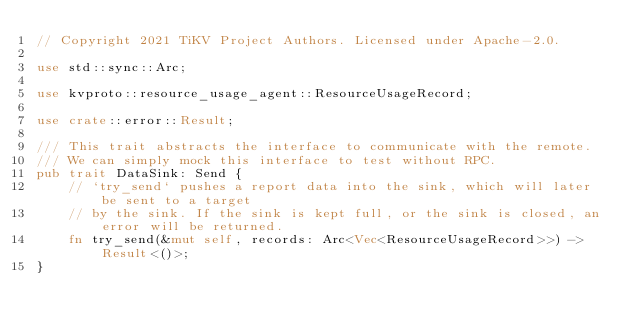<code> <loc_0><loc_0><loc_500><loc_500><_Rust_>// Copyright 2021 TiKV Project Authors. Licensed under Apache-2.0.

use std::sync::Arc;

use kvproto::resource_usage_agent::ResourceUsageRecord;

use crate::error::Result;

/// This trait abstracts the interface to communicate with the remote.
/// We can simply mock this interface to test without RPC.
pub trait DataSink: Send {
    // `try_send` pushes a report data into the sink, which will later be sent to a target
    // by the sink. If the sink is kept full, or the sink is closed, an error will be returned.
    fn try_send(&mut self, records: Arc<Vec<ResourceUsageRecord>>) -> Result<()>;
}
</code> 